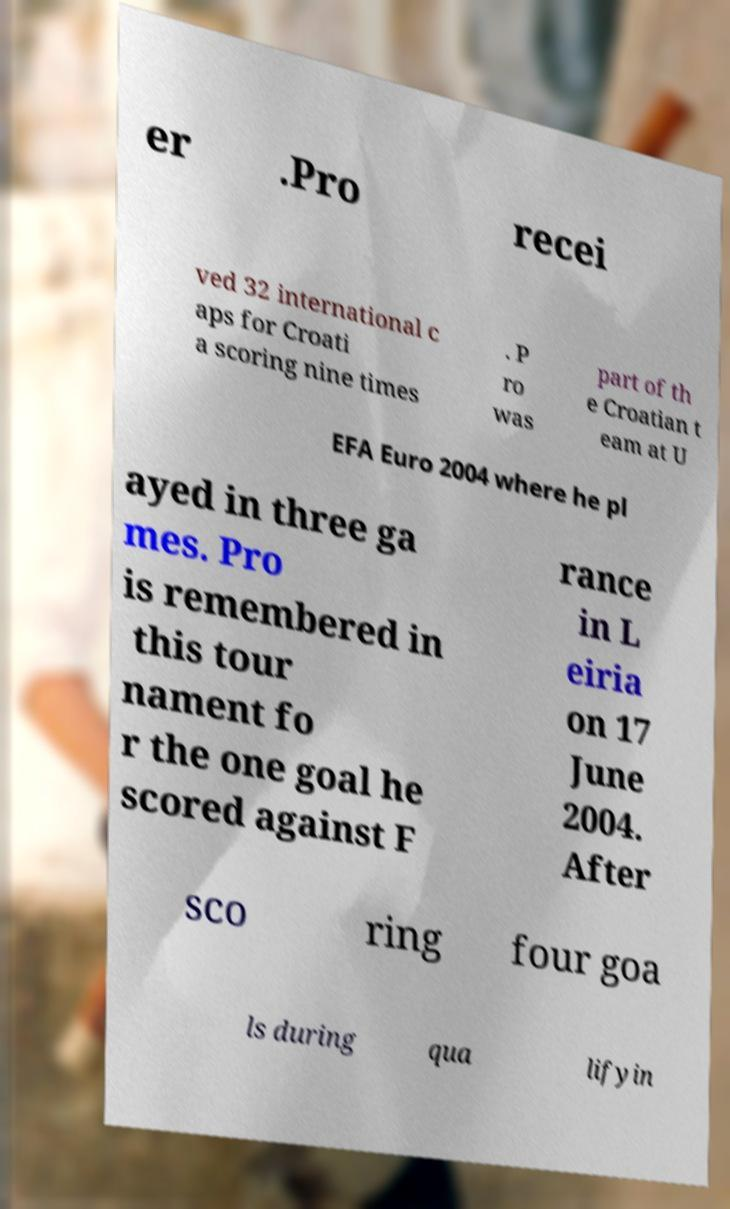Could you extract and type out the text from this image? er .Pro recei ved 32 international c aps for Croati a scoring nine times . P ro was part of th e Croatian t eam at U EFA Euro 2004 where he pl ayed in three ga mes. Pro is remembered in this tour nament fo r the one goal he scored against F rance in L eiria on 17 June 2004. After sco ring four goa ls during qua lifyin 